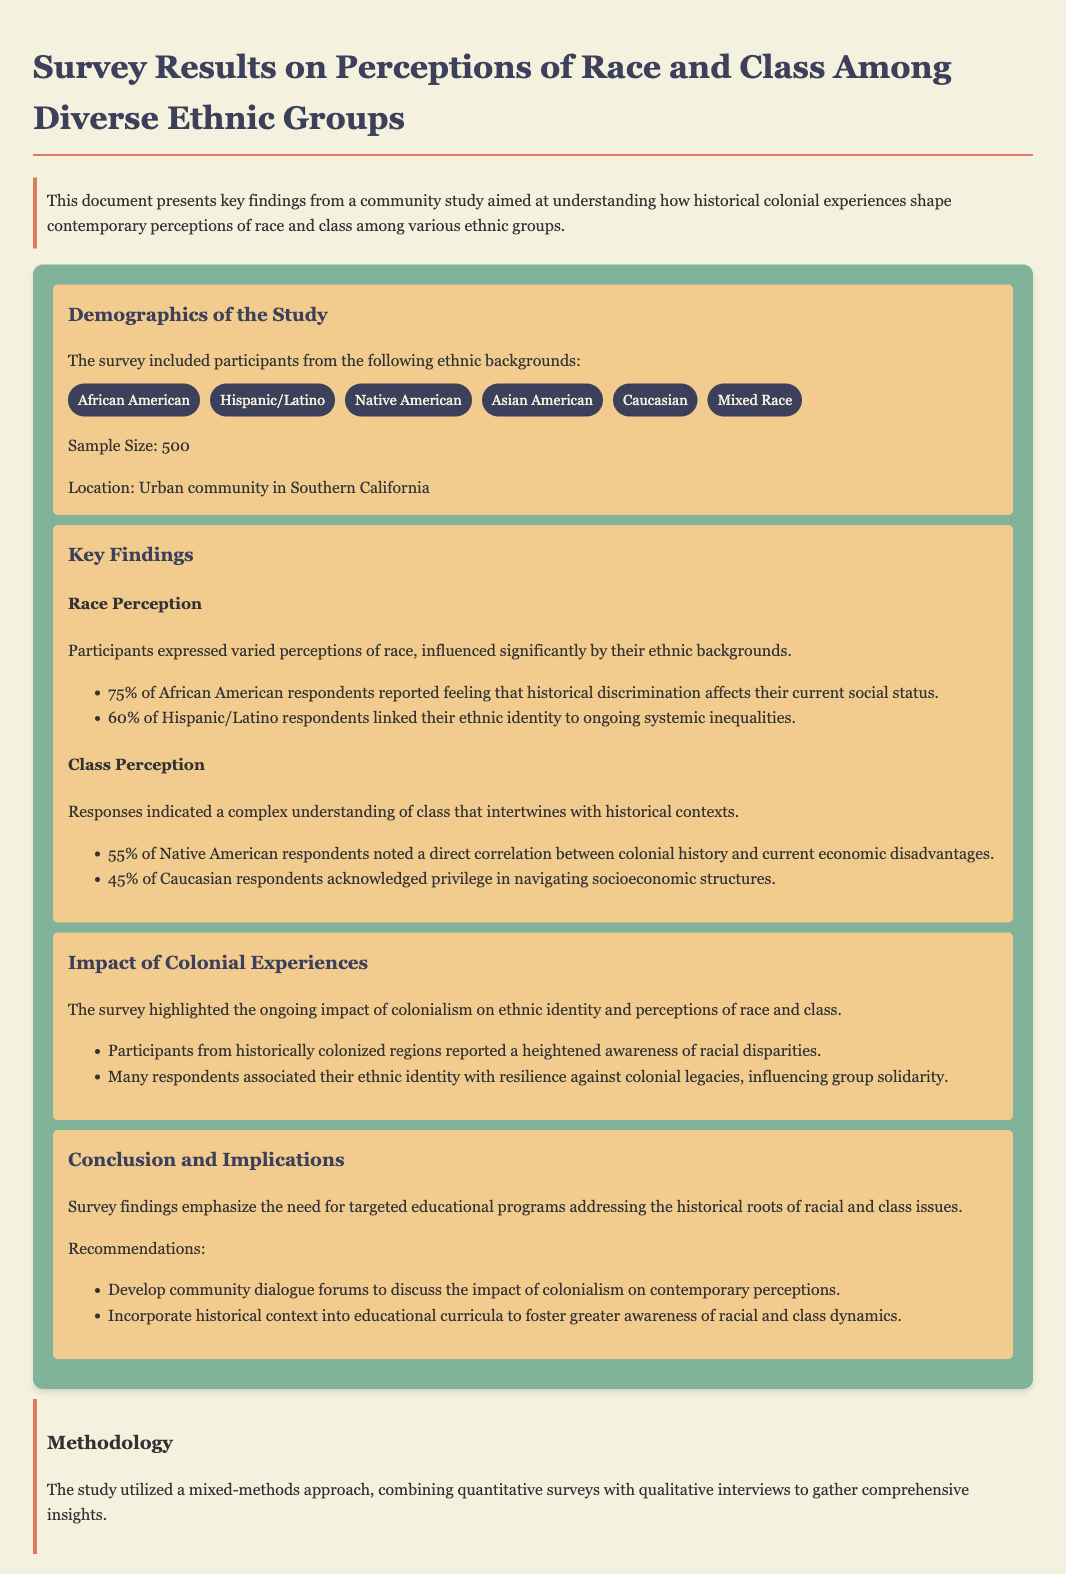What was the sample size of the study? The sample size is explicitly stated in the demographics section of the document as 500 participants.
Answer: 500 Which ethnic background linked their identity to ongoing systemic inequalities? The document specifies that 60% of Hispanic/Latino respondents linked their ethnic identity to ongoing systemic inequalities.
Answer: Hispanic/Latino What percentage of Native American respondents noted a correlation between colonial history and current economic disadvantages? The document states that 55% of Native American respondents noted this correlation, requiring reasoning on the impact of colonial experiences.
Answer: 55% What two types of methods were used in the study? The methodology section indicates a mixed-methods approach, combining both quantitative surveys and qualitative interviews.
Answer: Quantitative surveys and qualitative interviews What is one recommendation mentioned in the conclusion? The recommendations include developing community dialogue forums, which emphasize specific actions to address issues of race and class.
Answer: Develop community dialogue forums 